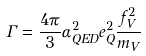<formula> <loc_0><loc_0><loc_500><loc_500>\Gamma = \frac { 4 \pi } { 3 } \alpha _ { Q E D } ^ { 2 } e _ { Q } ^ { 2 } \frac { f _ { V } ^ { 2 } } { m _ { V } }</formula> 